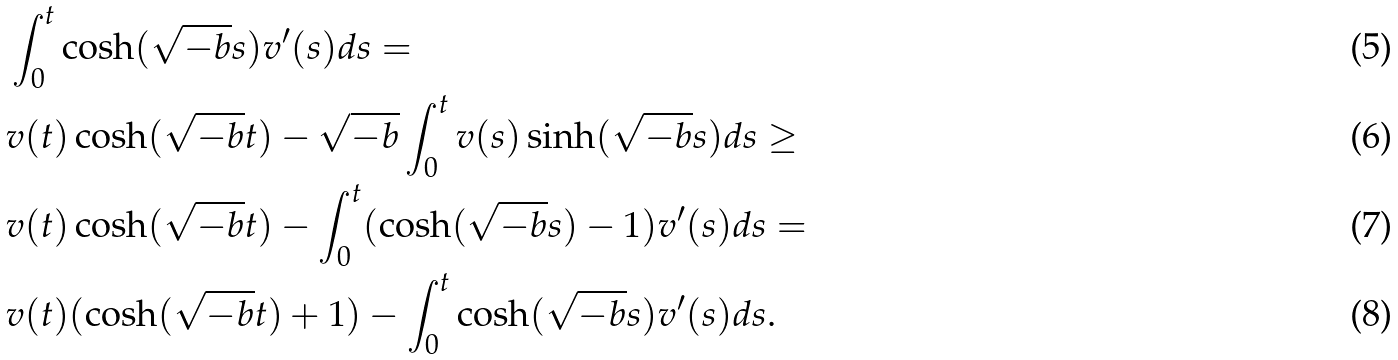Convert formula to latex. <formula><loc_0><loc_0><loc_500><loc_500>& \int _ { 0 } ^ { t } \cosh ( \sqrt { - b } s ) v ^ { \prime } ( s ) d s = \\ & v ( t ) \cosh ( \sqrt { - b } t ) - \sqrt { - b } \int _ { 0 } ^ { t } v ( s ) \sinh ( \sqrt { - b } s ) d s \geq \\ & v ( t ) \cosh ( \sqrt { - b } t ) - \int _ { 0 } ^ { t } ( \cosh ( \sqrt { - b } s ) - 1 ) v ^ { \prime } ( s ) d s = \\ & v ( t ) ( \cosh ( \sqrt { - b } t ) + 1 ) - \int _ { 0 } ^ { t } \cosh ( \sqrt { - b } s ) v ^ { \prime } ( s ) d s .</formula> 